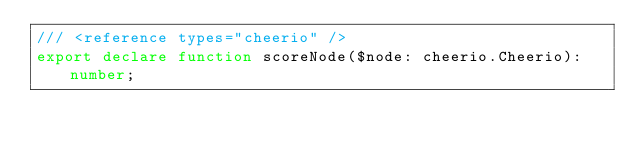Convert code to text. <code><loc_0><loc_0><loc_500><loc_500><_TypeScript_>/// <reference types="cheerio" />
export declare function scoreNode($node: cheerio.Cheerio): number;
</code> 